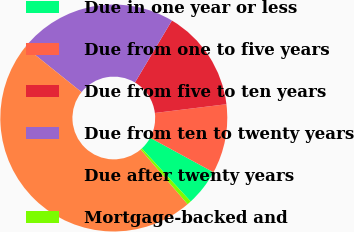<chart> <loc_0><loc_0><loc_500><loc_500><pie_chart><fcel>Due in one year or less<fcel>Due from one to five years<fcel>Due from five to ten years<fcel>Due from ten to twenty years<fcel>Due after twenty years<fcel>Mortgage-backed and<nl><fcel>5.22%<fcel>9.87%<fcel>14.51%<fcel>22.79%<fcel>47.03%<fcel>0.58%<nl></chart> 